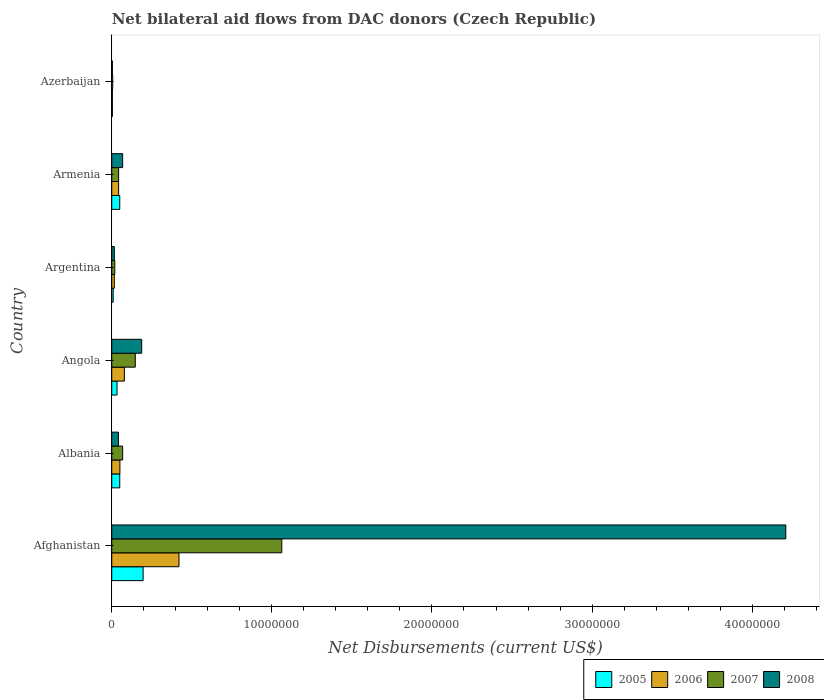How many different coloured bars are there?
Your answer should be very brief. 4. Are the number of bars per tick equal to the number of legend labels?
Give a very brief answer. Yes. Are the number of bars on each tick of the Y-axis equal?
Offer a very short reply. Yes. How many bars are there on the 1st tick from the bottom?
Give a very brief answer. 4. What is the label of the 5th group of bars from the top?
Provide a short and direct response. Albania. Across all countries, what is the maximum net bilateral aid flows in 2008?
Your response must be concise. 4.21e+07. In which country was the net bilateral aid flows in 2008 maximum?
Your answer should be compact. Afghanistan. In which country was the net bilateral aid flows in 2006 minimum?
Give a very brief answer. Azerbaijan. What is the total net bilateral aid flows in 2005 in the graph?
Provide a succinct answer. 3.42e+06. What is the difference between the net bilateral aid flows in 2006 in Afghanistan and the net bilateral aid flows in 2007 in Angola?
Provide a succinct answer. 2.73e+06. What is the average net bilateral aid flows in 2008 per country?
Ensure brevity in your answer.  7.54e+06. What is the ratio of the net bilateral aid flows in 2006 in Argentina to that in Armenia?
Your response must be concise. 0.37. Is the net bilateral aid flows in 2007 in Angola less than that in Argentina?
Your answer should be compact. No. Is the difference between the net bilateral aid flows in 2006 in Argentina and Azerbaijan greater than the difference between the net bilateral aid flows in 2005 in Argentina and Azerbaijan?
Your answer should be very brief. Yes. What is the difference between the highest and the second highest net bilateral aid flows in 2006?
Your response must be concise. 3.41e+06. What is the difference between the highest and the lowest net bilateral aid flows in 2007?
Offer a terse response. 1.06e+07. Is the sum of the net bilateral aid flows in 2008 in Afghanistan and Albania greater than the maximum net bilateral aid flows in 2006 across all countries?
Give a very brief answer. Yes. Is it the case that in every country, the sum of the net bilateral aid flows in 2005 and net bilateral aid flows in 2006 is greater than the sum of net bilateral aid flows in 2008 and net bilateral aid flows in 2007?
Make the answer very short. No. What does the 1st bar from the top in Albania represents?
Your answer should be compact. 2008. Is it the case that in every country, the sum of the net bilateral aid flows in 2008 and net bilateral aid flows in 2006 is greater than the net bilateral aid flows in 2005?
Ensure brevity in your answer.  Yes. Are all the bars in the graph horizontal?
Your answer should be compact. Yes. What is the title of the graph?
Keep it short and to the point. Net bilateral aid flows from DAC donors (Czech Republic). Does "1999" appear as one of the legend labels in the graph?
Ensure brevity in your answer.  No. What is the label or title of the X-axis?
Your answer should be compact. Net Disbursements (current US$). What is the label or title of the Y-axis?
Keep it short and to the point. Country. What is the Net Disbursements (current US$) in 2005 in Afghanistan?
Provide a short and direct response. 1.96e+06. What is the Net Disbursements (current US$) in 2006 in Afghanistan?
Provide a short and direct response. 4.20e+06. What is the Net Disbursements (current US$) in 2007 in Afghanistan?
Provide a short and direct response. 1.06e+07. What is the Net Disbursements (current US$) of 2008 in Afghanistan?
Provide a succinct answer. 4.21e+07. What is the Net Disbursements (current US$) in 2005 in Albania?
Provide a short and direct response. 5.00e+05. What is the Net Disbursements (current US$) of 2006 in Albania?
Make the answer very short. 5.10e+05. What is the Net Disbursements (current US$) in 2007 in Albania?
Your response must be concise. 6.80e+05. What is the Net Disbursements (current US$) of 2008 in Albania?
Your response must be concise. 4.20e+05. What is the Net Disbursements (current US$) in 2006 in Angola?
Provide a short and direct response. 7.90e+05. What is the Net Disbursements (current US$) in 2007 in Angola?
Offer a terse response. 1.47e+06. What is the Net Disbursements (current US$) in 2008 in Angola?
Give a very brief answer. 1.87e+06. What is the Net Disbursements (current US$) of 2006 in Argentina?
Your response must be concise. 1.60e+05. What is the Net Disbursements (current US$) of 2008 in Argentina?
Provide a short and direct response. 1.60e+05. What is the Net Disbursements (current US$) in 2005 in Armenia?
Your answer should be very brief. 5.00e+05. What is the Net Disbursements (current US$) in 2008 in Armenia?
Your response must be concise. 6.80e+05. What is the Net Disbursements (current US$) of 2005 in Azerbaijan?
Offer a very short reply. 4.00e+04. What is the Net Disbursements (current US$) in 2007 in Azerbaijan?
Provide a short and direct response. 6.00e+04. What is the Net Disbursements (current US$) of 2008 in Azerbaijan?
Your answer should be compact. 4.00e+04. Across all countries, what is the maximum Net Disbursements (current US$) in 2005?
Keep it short and to the point. 1.96e+06. Across all countries, what is the maximum Net Disbursements (current US$) of 2006?
Keep it short and to the point. 4.20e+06. Across all countries, what is the maximum Net Disbursements (current US$) of 2007?
Keep it short and to the point. 1.06e+07. Across all countries, what is the maximum Net Disbursements (current US$) of 2008?
Your answer should be very brief. 4.21e+07. Across all countries, what is the minimum Net Disbursements (current US$) of 2006?
Offer a very short reply. 4.00e+04. Across all countries, what is the minimum Net Disbursements (current US$) in 2007?
Offer a terse response. 6.00e+04. Across all countries, what is the minimum Net Disbursements (current US$) in 2008?
Your answer should be very brief. 4.00e+04. What is the total Net Disbursements (current US$) of 2005 in the graph?
Your answer should be very brief. 3.42e+06. What is the total Net Disbursements (current US$) of 2006 in the graph?
Provide a short and direct response. 6.13e+06. What is the total Net Disbursements (current US$) in 2007 in the graph?
Your response must be concise. 1.34e+07. What is the total Net Disbursements (current US$) of 2008 in the graph?
Your answer should be very brief. 4.53e+07. What is the difference between the Net Disbursements (current US$) in 2005 in Afghanistan and that in Albania?
Provide a succinct answer. 1.46e+06. What is the difference between the Net Disbursements (current US$) of 2006 in Afghanistan and that in Albania?
Keep it short and to the point. 3.69e+06. What is the difference between the Net Disbursements (current US$) of 2007 in Afghanistan and that in Albania?
Make the answer very short. 9.94e+06. What is the difference between the Net Disbursements (current US$) in 2008 in Afghanistan and that in Albania?
Provide a succinct answer. 4.17e+07. What is the difference between the Net Disbursements (current US$) in 2005 in Afghanistan and that in Angola?
Your answer should be very brief. 1.63e+06. What is the difference between the Net Disbursements (current US$) in 2006 in Afghanistan and that in Angola?
Offer a terse response. 3.41e+06. What is the difference between the Net Disbursements (current US$) in 2007 in Afghanistan and that in Angola?
Your response must be concise. 9.15e+06. What is the difference between the Net Disbursements (current US$) of 2008 in Afghanistan and that in Angola?
Make the answer very short. 4.02e+07. What is the difference between the Net Disbursements (current US$) in 2005 in Afghanistan and that in Argentina?
Offer a terse response. 1.87e+06. What is the difference between the Net Disbursements (current US$) of 2006 in Afghanistan and that in Argentina?
Offer a terse response. 4.04e+06. What is the difference between the Net Disbursements (current US$) in 2007 in Afghanistan and that in Argentina?
Keep it short and to the point. 1.04e+07. What is the difference between the Net Disbursements (current US$) in 2008 in Afghanistan and that in Argentina?
Ensure brevity in your answer.  4.19e+07. What is the difference between the Net Disbursements (current US$) in 2005 in Afghanistan and that in Armenia?
Provide a short and direct response. 1.46e+06. What is the difference between the Net Disbursements (current US$) of 2006 in Afghanistan and that in Armenia?
Ensure brevity in your answer.  3.77e+06. What is the difference between the Net Disbursements (current US$) of 2007 in Afghanistan and that in Armenia?
Provide a succinct answer. 1.02e+07. What is the difference between the Net Disbursements (current US$) of 2008 in Afghanistan and that in Armenia?
Provide a succinct answer. 4.14e+07. What is the difference between the Net Disbursements (current US$) of 2005 in Afghanistan and that in Azerbaijan?
Give a very brief answer. 1.92e+06. What is the difference between the Net Disbursements (current US$) in 2006 in Afghanistan and that in Azerbaijan?
Your answer should be very brief. 4.16e+06. What is the difference between the Net Disbursements (current US$) of 2007 in Afghanistan and that in Azerbaijan?
Your answer should be compact. 1.06e+07. What is the difference between the Net Disbursements (current US$) of 2008 in Afghanistan and that in Azerbaijan?
Provide a short and direct response. 4.21e+07. What is the difference between the Net Disbursements (current US$) in 2006 in Albania and that in Angola?
Offer a terse response. -2.80e+05. What is the difference between the Net Disbursements (current US$) of 2007 in Albania and that in Angola?
Give a very brief answer. -7.90e+05. What is the difference between the Net Disbursements (current US$) of 2008 in Albania and that in Angola?
Your answer should be very brief. -1.45e+06. What is the difference between the Net Disbursements (current US$) in 2005 in Albania and that in Argentina?
Provide a succinct answer. 4.10e+05. What is the difference between the Net Disbursements (current US$) in 2007 in Albania and that in Argentina?
Keep it short and to the point. 4.90e+05. What is the difference between the Net Disbursements (current US$) of 2005 in Albania and that in Armenia?
Your answer should be compact. 0. What is the difference between the Net Disbursements (current US$) in 2007 in Albania and that in Armenia?
Ensure brevity in your answer.  2.50e+05. What is the difference between the Net Disbursements (current US$) of 2008 in Albania and that in Armenia?
Keep it short and to the point. -2.60e+05. What is the difference between the Net Disbursements (current US$) of 2005 in Albania and that in Azerbaijan?
Give a very brief answer. 4.60e+05. What is the difference between the Net Disbursements (current US$) in 2006 in Albania and that in Azerbaijan?
Give a very brief answer. 4.70e+05. What is the difference between the Net Disbursements (current US$) in 2007 in Albania and that in Azerbaijan?
Your answer should be compact. 6.20e+05. What is the difference between the Net Disbursements (current US$) of 2008 in Albania and that in Azerbaijan?
Your answer should be very brief. 3.80e+05. What is the difference between the Net Disbursements (current US$) in 2006 in Angola and that in Argentina?
Provide a succinct answer. 6.30e+05. What is the difference between the Net Disbursements (current US$) in 2007 in Angola and that in Argentina?
Keep it short and to the point. 1.28e+06. What is the difference between the Net Disbursements (current US$) in 2008 in Angola and that in Argentina?
Give a very brief answer. 1.71e+06. What is the difference between the Net Disbursements (current US$) in 2007 in Angola and that in Armenia?
Ensure brevity in your answer.  1.04e+06. What is the difference between the Net Disbursements (current US$) in 2008 in Angola and that in Armenia?
Your answer should be very brief. 1.19e+06. What is the difference between the Net Disbursements (current US$) in 2006 in Angola and that in Azerbaijan?
Provide a short and direct response. 7.50e+05. What is the difference between the Net Disbursements (current US$) of 2007 in Angola and that in Azerbaijan?
Your answer should be compact. 1.41e+06. What is the difference between the Net Disbursements (current US$) in 2008 in Angola and that in Azerbaijan?
Your answer should be very brief. 1.83e+06. What is the difference between the Net Disbursements (current US$) of 2005 in Argentina and that in Armenia?
Make the answer very short. -4.10e+05. What is the difference between the Net Disbursements (current US$) of 2006 in Argentina and that in Armenia?
Provide a short and direct response. -2.70e+05. What is the difference between the Net Disbursements (current US$) of 2007 in Argentina and that in Armenia?
Offer a terse response. -2.40e+05. What is the difference between the Net Disbursements (current US$) of 2008 in Argentina and that in Armenia?
Your answer should be very brief. -5.20e+05. What is the difference between the Net Disbursements (current US$) in 2008 in Argentina and that in Azerbaijan?
Provide a succinct answer. 1.20e+05. What is the difference between the Net Disbursements (current US$) of 2005 in Armenia and that in Azerbaijan?
Give a very brief answer. 4.60e+05. What is the difference between the Net Disbursements (current US$) of 2008 in Armenia and that in Azerbaijan?
Your answer should be very brief. 6.40e+05. What is the difference between the Net Disbursements (current US$) in 2005 in Afghanistan and the Net Disbursements (current US$) in 2006 in Albania?
Your response must be concise. 1.45e+06. What is the difference between the Net Disbursements (current US$) of 2005 in Afghanistan and the Net Disbursements (current US$) of 2007 in Albania?
Give a very brief answer. 1.28e+06. What is the difference between the Net Disbursements (current US$) of 2005 in Afghanistan and the Net Disbursements (current US$) of 2008 in Albania?
Your answer should be very brief. 1.54e+06. What is the difference between the Net Disbursements (current US$) in 2006 in Afghanistan and the Net Disbursements (current US$) in 2007 in Albania?
Your answer should be compact. 3.52e+06. What is the difference between the Net Disbursements (current US$) of 2006 in Afghanistan and the Net Disbursements (current US$) of 2008 in Albania?
Keep it short and to the point. 3.78e+06. What is the difference between the Net Disbursements (current US$) in 2007 in Afghanistan and the Net Disbursements (current US$) in 2008 in Albania?
Keep it short and to the point. 1.02e+07. What is the difference between the Net Disbursements (current US$) of 2005 in Afghanistan and the Net Disbursements (current US$) of 2006 in Angola?
Offer a terse response. 1.17e+06. What is the difference between the Net Disbursements (current US$) of 2005 in Afghanistan and the Net Disbursements (current US$) of 2007 in Angola?
Provide a succinct answer. 4.90e+05. What is the difference between the Net Disbursements (current US$) of 2005 in Afghanistan and the Net Disbursements (current US$) of 2008 in Angola?
Keep it short and to the point. 9.00e+04. What is the difference between the Net Disbursements (current US$) of 2006 in Afghanistan and the Net Disbursements (current US$) of 2007 in Angola?
Ensure brevity in your answer.  2.73e+06. What is the difference between the Net Disbursements (current US$) of 2006 in Afghanistan and the Net Disbursements (current US$) of 2008 in Angola?
Your answer should be compact. 2.33e+06. What is the difference between the Net Disbursements (current US$) in 2007 in Afghanistan and the Net Disbursements (current US$) in 2008 in Angola?
Your answer should be very brief. 8.75e+06. What is the difference between the Net Disbursements (current US$) in 2005 in Afghanistan and the Net Disbursements (current US$) in 2006 in Argentina?
Your answer should be very brief. 1.80e+06. What is the difference between the Net Disbursements (current US$) of 2005 in Afghanistan and the Net Disbursements (current US$) of 2007 in Argentina?
Offer a terse response. 1.77e+06. What is the difference between the Net Disbursements (current US$) in 2005 in Afghanistan and the Net Disbursements (current US$) in 2008 in Argentina?
Keep it short and to the point. 1.80e+06. What is the difference between the Net Disbursements (current US$) in 2006 in Afghanistan and the Net Disbursements (current US$) in 2007 in Argentina?
Ensure brevity in your answer.  4.01e+06. What is the difference between the Net Disbursements (current US$) of 2006 in Afghanistan and the Net Disbursements (current US$) of 2008 in Argentina?
Your answer should be compact. 4.04e+06. What is the difference between the Net Disbursements (current US$) of 2007 in Afghanistan and the Net Disbursements (current US$) of 2008 in Argentina?
Make the answer very short. 1.05e+07. What is the difference between the Net Disbursements (current US$) in 2005 in Afghanistan and the Net Disbursements (current US$) in 2006 in Armenia?
Offer a terse response. 1.53e+06. What is the difference between the Net Disbursements (current US$) in 2005 in Afghanistan and the Net Disbursements (current US$) in 2007 in Armenia?
Provide a short and direct response. 1.53e+06. What is the difference between the Net Disbursements (current US$) of 2005 in Afghanistan and the Net Disbursements (current US$) of 2008 in Armenia?
Ensure brevity in your answer.  1.28e+06. What is the difference between the Net Disbursements (current US$) in 2006 in Afghanistan and the Net Disbursements (current US$) in 2007 in Armenia?
Provide a short and direct response. 3.77e+06. What is the difference between the Net Disbursements (current US$) in 2006 in Afghanistan and the Net Disbursements (current US$) in 2008 in Armenia?
Offer a terse response. 3.52e+06. What is the difference between the Net Disbursements (current US$) in 2007 in Afghanistan and the Net Disbursements (current US$) in 2008 in Armenia?
Give a very brief answer. 9.94e+06. What is the difference between the Net Disbursements (current US$) in 2005 in Afghanistan and the Net Disbursements (current US$) in 2006 in Azerbaijan?
Make the answer very short. 1.92e+06. What is the difference between the Net Disbursements (current US$) of 2005 in Afghanistan and the Net Disbursements (current US$) of 2007 in Azerbaijan?
Offer a very short reply. 1.90e+06. What is the difference between the Net Disbursements (current US$) in 2005 in Afghanistan and the Net Disbursements (current US$) in 2008 in Azerbaijan?
Ensure brevity in your answer.  1.92e+06. What is the difference between the Net Disbursements (current US$) in 2006 in Afghanistan and the Net Disbursements (current US$) in 2007 in Azerbaijan?
Make the answer very short. 4.14e+06. What is the difference between the Net Disbursements (current US$) in 2006 in Afghanistan and the Net Disbursements (current US$) in 2008 in Azerbaijan?
Offer a very short reply. 4.16e+06. What is the difference between the Net Disbursements (current US$) in 2007 in Afghanistan and the Net Disbursements (current US$) in 2008 in Azerbaijan?
Provide a short and direct response. 1.06e+07. What is the difference between the Net Disbursements (current US$) of 2005 in Albania and the Net Disbursements (current US$) of 2006 in Angola?
Keep it short and to the point. -2.90e+05. What is the difference between the Net Disbursements (current US$) of 2005 in Albania and the Net Disbursements (current US$) of 2007 in Angola?
Give a very brief answer. -9.70e+05. What is the difference between the Net Disbursements (current US$) of 2005 in Albania and the Net Disbursements (current US$) of 2008 in Angola?
Give a very brief answer. -1.37e+06. What is the difference between the Net Disbursements (current US$) of 2006 in Albania and the Net Disbursements (current US$) of 2007 in Angola?
Give a very brief answer. -9.60e+05. What is the difference between the Net Disbursements (current US$) of 2006 in Albania and the Net Disbursements (current US$) of 2008 in Angola?
Make the answer very short. -1.36e+06. What is the difference between the Net Disbursements (current US$) of 2007 in Albania and the Net Disbursements (current US$) of 2008 in Angola?
Keep it short and to the point. -1.19e+06. What is the difference between the Net Disbursements (current US$) of 2006 in Albania and the Net Disbursements (current US$) of 2008 in Argentina?
Ensure brevity in your answer.  3.50e+05. What is the difference between the Net Disbursements (current US$) in 2007 in Albania and the Net Disbursements (current US$) in 2008 in Argentina?
Give a very brief answer. 5.20e+05. What is the difference between the Net Disbursements (current US$) in 2006 in Albania and the Net Disbursements (current US$) in 2008 in Armenia?
Your response must be concise. -1.70e+05. What is the difference between the Net Disbursements (current US$) in 2005 in Albania and the Net Disbursements (current US$) in 2006 in Azerbaijan?
Ensure brevity in your answer.  4.60e+05. What is the difference between the Net Disbursements (current US$) of 2006 in Albania and the Net Disbursements (current US$) of 2008 in Azerbaijan?
Your answer should be very brief. 4.70e+05. What is the difference between the Net Disbursements (current US$) of 2007 in Albania and the Net Disbursements (current US$) of 2008 in Azerbaijan?
Provide a succinct answer. 6.40e+05. What is the difference between the Net Disbursements (current US$) of 2005 in Angola and the Net Disbursements (current US$) of 2008 in Argentina?
Your answer should be very brief. 1.70e+05. What is the difference between the Net Disbursements (current US$) of 2006 in Angola and the Net Disbursements (current US$) of 2007 in Argentina?
Your answer should be compact. 6.00e+05. What is the difference between the Net Disbursements (current US$) in 2006 in Angola and the Net Disbursements (current US$) in 2008 in Argentina?
Ensure brevity in your answer.  6.30e+05. What is the difference between the Net Disbursements (current US$) in 2007 in Angola and the Net Disbursements (current US$) in 2008 in Argentina?
Keep it short and to the point. 1.31e+06. What is the difference between the Net Disbursements (current US$) of 2005 in Angola and the Net Disbursements (current US$) of 2008 in Armenia?
Offer a terse response. -3.50e+05. What is the difference between the Net Disbursements (current US$) of 2006 in Angola and the Net Disbursements (current US$) of 2007 in Armenia?
Keep it short and to the point. 3.60e+05. What is the difference between the Net Disbursements (current US$) in 2007 in Angola and the Net Disbursements (current US$) in 2008 in Armenia?
Ensure brevity in your answer.  7.90e+05. What is the difference between the Net Disbursements (current US$) in 2005 in Angola and the Net Disbursements (current US$) in 2007 in Azerbaijan?
Offer a very short reply. 2.70e+05. What is the difference between the Net Disbursements (current US$) of 2005 in Angola and the Net Disbursements (current US$) of 2008 in Azerbaijan?
Give a very brief answer. 2.90e+05. What is the difference between the Net Disbursements (current US$) in 2006 in Angola and the Net Disbursements (current US$) in 2007 in Azerbaijan?
Ensure brevity in your answer.  7.30e+05. What is the difference between the Net Disbursements (current US$) of 2006 in Angola and the Net Disbursements (current US$) of 2008 in Azerbaijan?
Your response must be concise. 7.50e+05. What is the difference between the Net Disbursements (current US$) of 2007 in Angola and the Net Disbursements (current US$) of 2008 in Azerbaijan?
Offer a very short reply. 1.43e+06. What is the difference between the Net Disbursements (current US$) in 2005 in Argentina and the Net Disbursements (current US$) in 2008 in Armenia?
Your response must be concise. -5.90e+05. What is the difference between the Net Disbursements (current US$) in 2006 in Argentina and the Net Disbursements (current US$) in 2008 in Armenia?
Your answer should be very brief. -5.20e+05. What is the difference between the Net Disbursements (current US$) in 2007 in Argentina and the Net Disbursements (current US$) in 2008 in Armenia?
Provide a short and direct response. -4.90e+05. What is the difference between the Net Disbursements (current US$) in 2005 in Argentina and the Net Disbursements (current US$) in 2006 in Azerbaijan?
Your response must be concise. 5.00e+04. What is the difference between the Net Disbursements (current US$) of 2006 in Argentina and the Net Disbursements (current US$) of 2007 in Azerbaijan?
Make the answer very short. 1.00e+05. What is the difference between the Net Disbursements (current US$) of 2006 in Armenia and the Net Disbursements (current US$) of 2007 in Azerbaijan?
Offer a terse response. 3.70e+05. What is the difference between the Net Disbursements (current US$) of 2006 in Armenia and the Net Disbursements (current US$) of 2008 in Azerbaijan?
Your response must be concise. 3.90e+05. What is the difference between the Net Disbursements (current US$) of 2007 in Armenia and the Net Disbursements (current US$) of 2008 in Azerbaijan?
Make the answer very short. 3.90e+05. What is the average Net Disbursements (current US$) in 2005 per country?
Your answer should be very brief. 5.70e+05. What is the average Net Disbursements (current US$) of 2006 per country?
Keep it short and to the point. 1.02e+06. What is the average Net Disbursements (current US$) of 2007 per country?
Your answer should be compact. 2.24e+06. What is the average Net Disbursements (current US$) of 2008 per country?
Provide a short and direct response. 7.54e+06. What is the difference between the Net Disbursements (current US$) in 2005 and Net Disbursements (current US$) in 2006 in Afghanistan?
Offer a very short reply. -2.24e+06. What is the difference between the Net Disbursements (current US$) in 2005 and Net Disbursements (current US$) in 2007 in Afghanistan?
Offer a very short reply. -8.66e+06. What is the difference between the Net Disbursements (current US$) in 2005 and Net Disbursements (current US$) in 2008 in Afghanistan?
Your response must be concise. -4.01e+07. What is the difference between the Net Disbursements (current US$) of 2006 and Net Disbursements (current US$) of 2007 in Afghanistan?
Offer a very short reply. -6.42e+06. What is the difference between the Net Disbursements (current US$) in 2006 and Net Disbursements (current US$) in 2008 in Afghanistan?
Your answer should be very brief. -3.79e+07. What is the difference between the Net Disbursements (current US$) in 2007 and Net Disbursements (current US$) in 2008 in Afghanistan?
Ensure brevity in your answer.  -3.15e+07. What is the difference between the Net Disbursements (current US$) in 2005 and Net Disbursements (current US$) in 2007 in Albania?
Give a very brief answer. -1.80e+05. What is the difference between the Net Disbursements (current US$) in 2006 and Net Disbursements (current US$) in 2007 in Albania?
Your answer should be compact. -1.70e+05. What is the difference between the Net Disbursements (current US$) in 2006 and Net Disbursements (current US$) in 2008 in Albania?
Your answer should be very brief. 9.00e+04. What is the difference between the Net Disbursements (current US$) of 2007 and Net Disbursements (current US$) of 2008 in Albania?
Provide a short and direct response. 2.60e+05. What is the difference between the Net Disbursements (current US$) of 2005 and Net Disbursements (current US$) of 2006 in Angola?
Offer a very short reply. -4.60e+05. What is the difference between the Net Disbursements (current US$) in 2005 and Net Disbursements (current US$) in 2007 in Angola?
Ensure brevity in your answer.  -1.14e+06. What is the difference between the Net Disbursements (current US$) in 2005 and Net Disbursements (current US$) in 2008 in Angola?
Your response must be concise. -1.54e+06. What is the difference between the Net Disbursements (current US$) of 2006 and Net Disbursements (current US$) of 2007 in Angola?
Your answer should be compact. -6.80e+05. What is the difference between the Net Disbursements (current US$) in 2006 and Net Disbursements (current US$) in 2008 in Angola?
Give a very brief answer. -1.08e+06. What is the difference between the Net Disbursements (current US$) of 2007 and Net Disbursements (current US$) of 2008 in Angola?
Your response must be concise. -4.00e+05. What is the difference between the Net Disbursements (current US$) in 2005 and Net Disbursements (current US$) in 2007 in Argentina?
Offer a very short reply. -1.00e+05. What is the difference between the Net Disbursements (current US$) of 2005 and Net Disbursements (current US$) of 2008 in Argentina?
Your answer should be very brief. -7.00e+04. What is the difference between the Net Disbursements (current US$) in 2006 and Net Disbursements (current US$) in 2007 in Argentina?
Provide a succinct answer. -3.00e+04. What is the difference between the Net Disbursements (current US$) in 2005 and Net Disbursements (current US$) in 2007 in Armenia?
Give a very brief answer. 7.00e+04. What is the difference between the Net Disbursements (current US$) of 2005 and Net Disbursements (current US$) of 2008 in Armenia?
Provide a succinct answer. -1.80e+05. What is the difference between the Net Disbursements (current US$) in 2006 and Net Disbursements (current US$) in 2007 in Armenia?
Your answer should be very brief. 0. What is the difference between the Net Disbursements (current US$) in 2006 and Net Disbursements (current US$) in 2008 in Armenia?
Keep it short and to the point. -2.50e+05. What is the difference between the Net Disbursements (current US$) in 2005 and Net Disbursements (current US$) in 2007 in Azerbaijan?
Provide a short and direct response. -2.00e+04. What is the difference between the Net Disbursements (current US$) in 2007 and Net Disbursements (current US$) in 2008 in Azerbaijan?
Provide a succinct answer. 2.00e+04. What is the ratio of the Net Disbursements (current US$) of 2005 in Afghanistan to that in Albania?
Your response must be concise. 3.92. What is the ratio of the Net Disbursements (current US$) in 2006 in Afghanistan to that in Albania?
Make the answer very short. 8.24. What is the ratio of the Net Disbursements (current US$) of 2007 in Afghanistan to that in Albania?
Your response must be concise. 15.62. What is the ratio of the Net Disbursements (current US$) of 2008 in Afghanistan to that in Albania?
Offer a very short reply. 100.24. What is the ratio of the Net Disbursements (current US$) of 2005 in Afghanistan to that in Angola?
Offer a very short reply. 5.94. What is the ratio of the Net Disbursements (current US$) of 2006 in Afghanistan to that in Angola?
Give a very brief answer. 5.32. What is the ratio of the Net Disbursements (current US$) of 2007 in Afghanistan to that in Angola?
Keep it short and to the point. 7.22. What is the ratio of the Net Disbursements (current US$) in 2008 in Afghanistan to that in Angola?
Ensure brevity in your answer.  22.51. What is the ratio of the Net Disbursements (current US$) in 2005 in Afghanistan to that in Argentina?
Provide a succinct answer. 21.78. What is the ratio of the Net Disbursements (current US$) in 2006 in Afghanistan to that in Argentina?
Provide a succinct answer. 26.25. What is the ratio of the Net Disbursements (current US$) in 2007 in Afghanistan to that in Argentina?
Your response must be concise. 55.89. What is the ratio of the Net Disbursements (current US$) of 2008 in Afghanistan to that in Argentina?
Give a very brief answer. 263.12. What is the ratio of the Net Disbursements (current US$) in 2005 in Afghanistan to that in Armenia?
Provide a short and direct response. 3.92. What is the ratio of the Net Disbursements (current US$) in 2006 in Afghanistan to that in Armenia?
Your answer should be compact. 9.77. What is the ratio of the Net Disbursements (current US$) of 2007 in Afghanistan to that in Armenia?
Make the answer very short. 24.7. What is the ratio of the Net Disbursements (current US$) in 2008 in Afghanistan to that in Armenia?
Ensure brevity in your answer.  61.91. What is the ratio of the Net Disbursements (current US$) in 2005 in Afghanistan to that in Azerbaijan?
Give a very brief answer. 49. What is the ratio of the Net Disbursements (current US$) in 2006 in Afghanistan to that in Azerbaijan?
Give a very brief answer. 105. What is the ratio of the Net Disbursements (current US$) in 2007 in Afghanistan to that in Azerbaijan?
Make the answer very short. 177. What is the ratio of the Net Disbursements (current US$) in 2008 in Afghanistan to that in Azerbaijan?
Provide a short and direct response. 1052.5. What is the ratio of the Net Disbursements (current US$) of 2005 in Albania to that in Angola?
Give a very brief answer. 1.52. What is the ratio of the Net Disbursements (current US$) in 2006 in Albania to that in Angola?
Your answer should be compact. 0.65. What is the ratio of the Net Disbursements (current US$) of 2007 in Albania to that in Angola?
Your answer should be very brief. 0.46. What is the ratio of the Net Disbursements (current US$) in 2008 in Albania to that in Angola?
Your answer should be very brief. 0.22. What is the ratio of the Net Disbursements (current US$) in 2005 in Albania to that in Argentina?
Give a very brief answer. 5.56. What is the ratio of the Net Disbursements (current US$) in 2006 in Albania to that in Argentina?
Your response must be concise. 3.19. What is the ratio of the Net Disbursements (current US$) in 2007 in Albania to that in Argentina?
Offer a terse response. 3.58. What is the ratio of the Net Disbursements (current US$) in 2008 in Albania to that in Argentina?
Provide a short and direct response. 2.62. What is the ratio of the Net Disbursements (current US$) of 2005 in Albania to that in Armenia?
Make the answer very short. 1. What is the ratio of the Net Disbursements (current US$) of 2006 in Albania to that in Armenia?
Your answer should be very brief. 1.19. What is the ratio of the Net Disbursements (current US$) in 2007 in Albania to that in Armenia?
Make the answer very short. 1.58. What is the ratio of the Net Disbursements (current US$) in 2008 in Albania to that in Armenia?
Keep it short and to the point. 0.62. What is the ratio of the Net Disbursements (current US$) of 2006 in Albania to that in Azerbaijan?
Your answer should be compact. 12.75. What is the ratio of the Net Disbursements (current US$) in 2007 in Albania to that in Azerbaijan?
Your response must be concise. 11.33. What is the ratio of the Net Disbursements (current US$) of 2008 in Albania to that in Azerbaijan?
Make the answer very short. 10.5. What is the ratio of the Net Disbursements (current US$) of 2005 in Angola to that in Argentina?
Offer a very short reply. 3.67. What is the ratio of the Net Disbursements (current US$) of 2006 in Angola to that in Argentina?
Provide a short and direct response. 4.94. What is the ratio of the Net Disbursements (current US$) in 2007 in Angola to that in Argentina?
Offer a terse response. 7.74. What is the ratio of the Net Disbursements (current US$) in 2008 in Angola to that in Argentina?
Your answer should be very brief. 11.69. What is the ratio of the Net Disbursements (current US$) of 2005 in Angola to that in Armenia?
Offer a very short reply. 0.66. What is the ratio of the Net Disbursements (current US$) of 2006 in Angola to that in Armenia?
Your answer should be compact. 1.84. What is the ratio of the Net Disbursements (current US$) in 2007 in Angola to that in Armenia?
Offer a terse response. 3.42. What is the ratio of the Net Disbursements (current US$) of 2008 in Angola to that in Armenia?
Your answer should be compact. 2.75. What is the ratio of the Net Disbursements (current US$) of 2005 in Angola to that in Azerbaijan?
Make the answer very short. 8.25. What is the ratio of the Net Disbursements (current US$) of 2006 in Angola to that in Azerbaijan?
Give a very brief answer. 19.75. What is the ratio of the Net Disbursements (current US$) of 2007 in Angola to that in Azerbaijan?
Offer a very short reply. 24.5. What is the ratio of the Net Disbursements (current US$) of 2008 in Angola to that in Azerbaijan?
Your answer should be compact. 46.75. What is the ratio of the Net Disbursements (current US$) of 2005 in Argentina to that in Armenia?
Make the answer very short. 0.18. What is the ratio of the Net Disbursements (current US$) of 2006 in Argentina to that in Armenia?
Your answer should be compact. 0.37. What is the ratio of the Net Disbursements (current US$) in 2007 in Argentina to that in Armenia?
Make the answer very short. 0.44. What is the ratio of the Net Disbursements (current US$) of 2008 in Argentina to that in Armenia?
Ensure brevity in your answer.  0.24. What is the ratio of the Net Disbursements (current US$) in 2005 in Argentina to that in Azerbaijan?
Make the answer very short. 2.25. What is the ratio of the Net Disbursements (current US$) of 2007 in Argentina to that in Azerbaijan?
Your answer should be compact. 3.17. What is the ratio of the Net Disbursements (current US$) in 2008 in Argentina to that in Azerbaijan?
Provide a succinct answer. 4. What is the ratio of the Net Disbursements (current US$) in 2006 in Armenia to that in Azerbaijan?
Offer a terse response. 10.75. What is the ratio of the Net Disbursements (current US$) of 2007 in Armenia to that in Azerbaijan?
Provide a short and direct response. 7.17. What is the ratio of the Net Disbursements (current US$) in 2008 in Armenia to that in Azerbaijan?
Provide a succinct answer. 17. What is the difference between the highest and the second highest Net Disbursements (current US$) of 2005?
Provide a succinct answer. 1.46e+06. What is the difference between the highest and the second highest Net Disbursements (current US$) of 2006?
Provide a succinct answer. 3.41e+06. What is the difference between the highest and the second highest Net Disbursements (current US$) of 2007?
Provide a short and direct response. 9.15e+06. What is the difference between the highest and the second highest Net Disbursements (current US$) of 2008?
Offer a terse response. 4.02e+07. What is the difference between the highest and the lowest Net Disbursements (current US$) of 2005?
Provide a short and direct response. 1.92e+06. What is the difference between the highest and the lowest Net Disbursements (current US$) of 2006?
Make the answer very short. 4.16e+06. What is the difference between the highest and the lowest Net Disbursements (current US$) of 2007?
Provide a succinct answer. 1.06e+07. What is the difference between the highest and the lowest Net Disbursements (current US$) of 2008?
Your answer should be compact. 4.21e+07. 